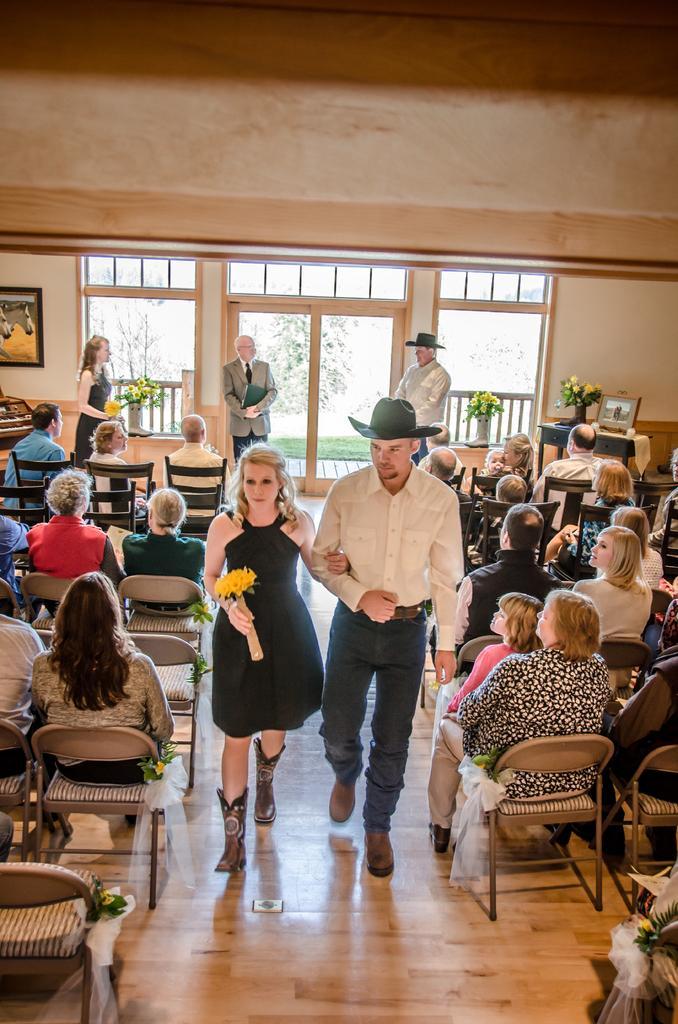In one or two sentences, can you explain what this image depicts? These two persons are walking, as there is a leg movement. This woman is holding a bouquet. These persons are sitting on a chair. Far these persons are standing. A picture on wall. On this table there is a bouquet and picture. 